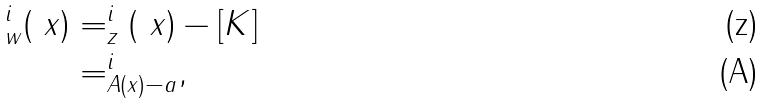Convert formula to latex. <formula><loc_0><loc_0><loc_500><loc_500>^ { i } _ { w } ( \ x ) & = ^ { i } _ { z } ( \ x ) - [ K ] \\ & = ^ { i } _ { A ( x ) - a } ,</formula> 